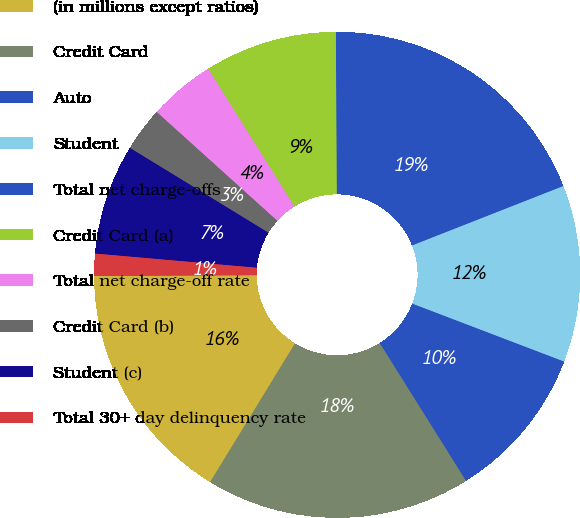Convert chart. <chart><loc_0><loc_0><loc_500><loc_500><pie_chart><fcel>(in millions except ratios)<fcel>Credit Card<fcel>Auto<fcel>Student<fcel>Total net charge-offs<fcel>Credit Card (a)<fcel>Total net charge-off rate<fcel>Credit Card (b)<fcel>Student (c)<fcel>Total 30+ day delinquency rate<nl><fcel>16.17%<fcel>17.65%<fcel>10.29%<fcel>11.76%<fcel>19.12%<fcel>8.82%<fcel>4.41%<fcel>2.94%<fcel>7.35%<fcel>1.47%<nl></chart> 